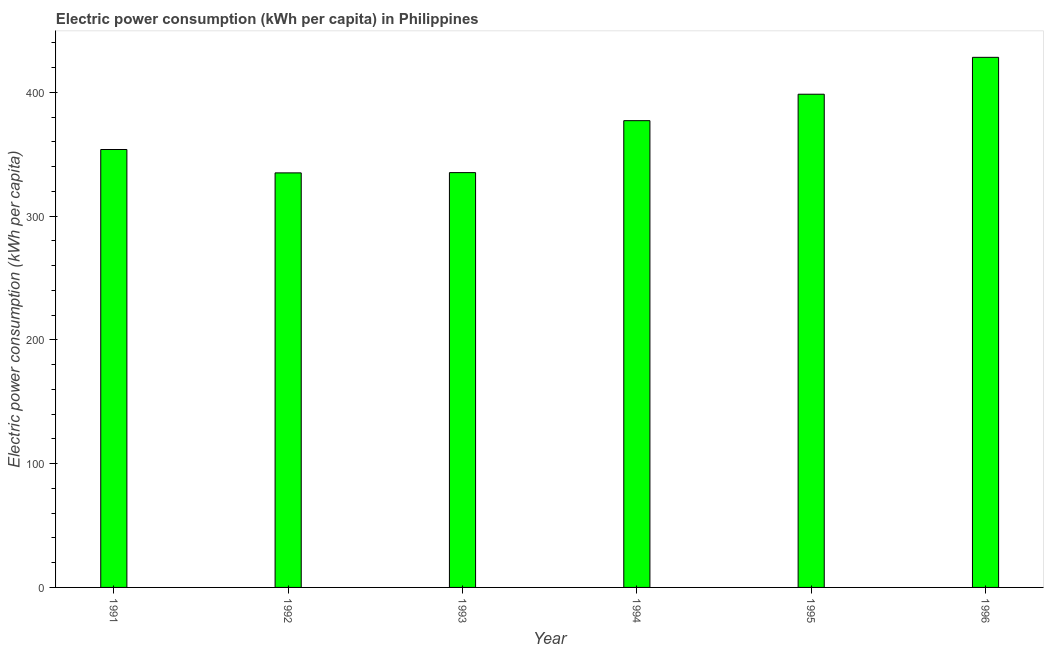Does the graph contain grids?
Ensure brevity in your answer.  No. What is the title of the graph?
Give a very brief answer. Electric power consumption (kWh per capita) in Philippines. What is the label or title of the X-axis?
Make the answer very short. Year. What is the label or title of the Y-axis?
Give a very brief answer. Electric power consumption (kWh per capita). What is the electric power consumption in 1992?
Offer a very short reply. 334.96. Across all years, what is the maximum electric power consumption?
Offer a terse response. 428.33. Across all years, what is the minimum electric power consumption?
Offer a very short reply. 334.96. What is the sum of the electric power consumption?
Ensure brevity in your answer.  2227.99. What is the difference between the electric power consumption in 1994 and 1995?
Keep it short and to the point. -21.37. What is the average electric power consumption per year?
Ensure brevity in your answer.  371.33. What is the median electric power consumption?
Offer a very short reply. 365.5. What is the ratio of the electric power consumption in 1994 to that in 1995?
Provide a short and direct response. 0.95. Is the electric power consumption in 1991 less than that in 1994?
Your response must be concise. Yes. Is the difference between the electric power consumption in 1994 and 1995 greater than the difference between any two years?
Ensure brevity in your answer.  No. What is the difference between the highest and the second highest electric power consumption?
Offer a very short reply. 29.81. What is the difference between the highest and the lowest electric power consumption?
Provide a succinct answer. 93.37. Are the values on the major ticks of Y-axis written in scientific E-notation?
Offer a very short reply. No. What is the Electric power consumption (kWh per capita) in 1991?
Ensure brevity in your answer.  353.85. What is the Electric power consumption (kWh per capita) of 1992?
Keep it short and to the point. 334.96. What is the Electric power consumption (kWh per capita) in 1993?
Provide a short and direct response. 335.17. What is the Electric power consumption (kWh per capita) in 1994?
Keep it short and to the point. 377.15. What is the Electric power consumption (kWh per capita) in 1995?
Your answer should be compact. 398.52. What is the Electric power consumption (kWh per capita) of 1996?
Provide a short and direct response. 428.33. What is the difference between the Electric power consumption (kWh per capita) in 1991 and 1992?
Offer a terse response. 18.89. What is the difference between the Electric power consumption (kWh per capita) in 1991 and 1993?
Keep it short and to the point. 18.68. What is the difference between the Electric power consumption (kWh per capita) in 1991 and 1994?
Offer a very short reply. -23.3. What is the difference between the Electric power consumption (kWh per capita) in 1991 and 1995?
Make the answer very short. -44.67. What is the difference between the Electric power consumption (kWh per capita) in 1991 and 1996?
Your answer should be compact. -74.48. What is the difference between the Electric power consumption (kWh per capita) in 1992 and 1993?
Ensure brevity in your answer.  -0.21. What is the difference between the Electric power consumption (kWh per capita) in 1992 and 1994?
Make the answer very short. -42.19. What is the difference between the Electric power consumption (kWh per capita) in 1992 and 1995?
Ensure brevity in your answer.  -63.56. What is the difference between the Electric power consumption (kWh per capita) in 1992 and 1996?
Offer a very short reply. -93.37. What is the difference between the Electric power consumption (kWh per capita) in 1993 and 1994?
Offer a very short reply. -41.98. What is the difference between the Electric power consumption (kWh per capita) in 1993 and 1995?
Provide a short and direct response. -63.35. What is the difference between the Electric power consumption (kWh per capita) in 1993 and 1996?
Your answer should be compact. -93.16. What is the difference between the Electric power consumption (kWh per capita) in 1994 and 1995?
Keep it short and to the point. -21.37. What is the difference between the Electric power consumption (kWh per capita) in 1994 and 1996?
Ensure brevity in your answer.  -51.18. What is the difference between the Electric power consumption (kWh per capita) in 1995 and 1996?
Offer a very short reply. -29.81. What is the ratio of the Electric power consumption (kWh per capita) in 1991 to that in 1992?
Your response must be concise. 1.06. What is the ratio of the Electric power consumption (kWh per capita) in 1991 to that in 1993?
Offer a terse response. 1.06. What is the ratio of the Electric power consumption (kWh per capita) in 1991 to that in 1994?
Offer a very short reply. 0.94. What is the ratio of the Electric power consumption (kWh per capita) in 1991 to that in 1995?
Give a very brief answer. 0.89. What is the ratio of the Electric power consumption (kWh per capita) in 1991 to that in 1996?
Your answer should be very brief. 0.83. What is the ratio of the Electric power consumption (kWh per capita) in 1992 to that in 1993?
Offer a terse response. 1. What is the ratio of the Electric power consumption (kWh per capita) in 1992 to that in 1994?
Ensure brevity in your answer.  0.89. What is the ratio of the Electric power consumption (kWh per capita) in 1992 to that in 1995?
Provide a short and direct response. 0.84. What is the ratio of the Electric power consumption (kWh per capita) in 1992 to that in 1996?
Give a very brief answer. 0.78. What is the ratio of the Electric power consumption (kWh per capita) in 1993 to that in 1994?
Ensure brevity in your answer.  0.89. What is the ratio of the Electric power consumption (kWh per capita) in 1993 to that in 1995?
Make the answer very short. 0.84. What is the ratio of the Electric power consumption (kWh per capita) in 1993 to that in 1996?
Make the answer very short. 0.78. What is the ratio of the Electric power consumption (kWh per capita) in 1994 to that in 1995?
Provide a succinct answer. 0.95. What is the ratio of the Electric power consumption (kWh per capita) in 1994 to that in 1996?
Your response must be concise. 0.88. What is the ratio of the Electric power consumption (kWh per capita) in 1995 to that in 1996?
Make the answer very short. 0.93. 